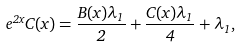Convert formula to latex. <formula><loc_0><loc_0><loc_500><loc_500>e ^ { 2 x } C ( x ) = \frac { B ( x ) \lambda _ { 1 } } { 2 } + \frac { C ( x ) \lambda _ { 1 } } { 4 } + \lambda _ { 1 } ,</formula> 